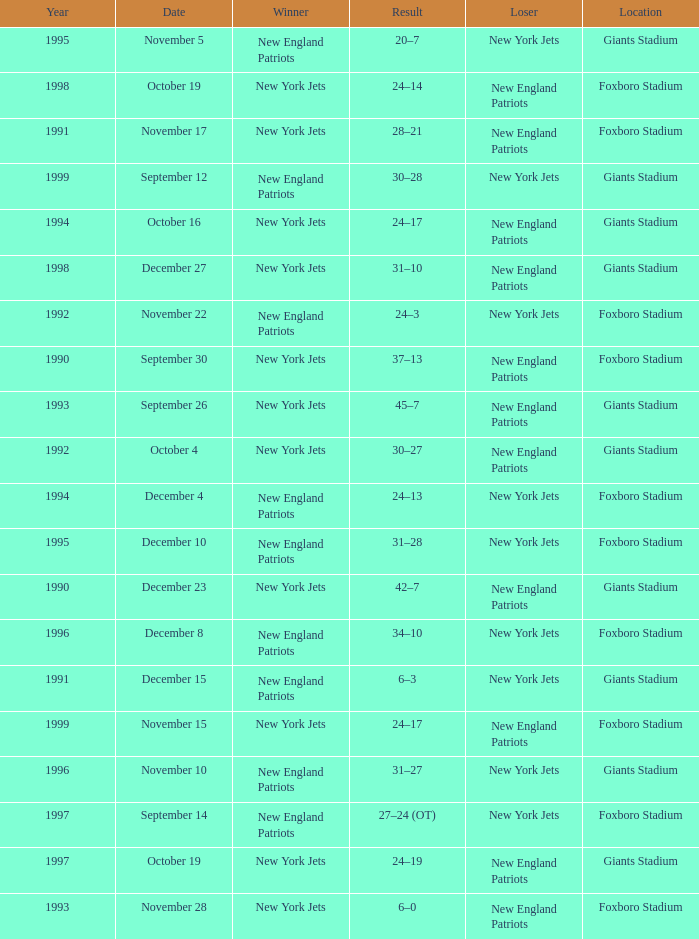What is the name of the Loser when the winner was new england patriots, and a Location of giants stadium, and a Result of 30–28? New York Jets. 